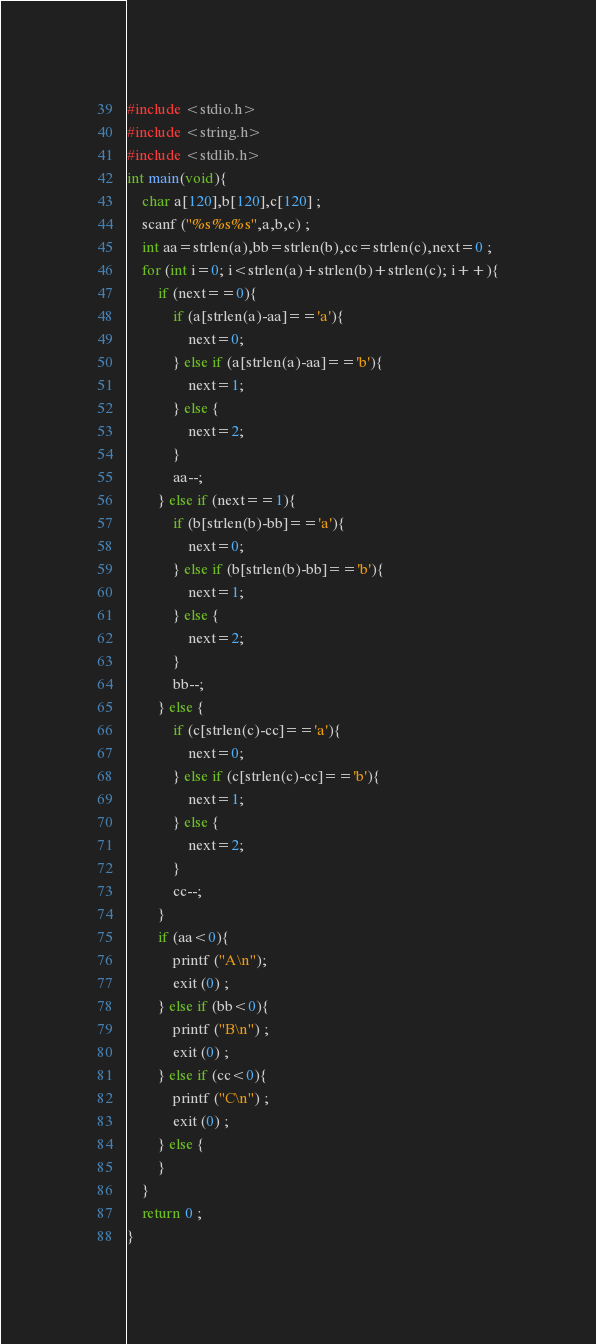<code> <loc_0><loc_0><loc_500><loc_500><_C_>#include <stdio.h>
#include <string.h>
#include <stdlib.h>
int main(void){
    char a[120],b[120],c[120] ;
    scanf ("%s%s%s",a,b,c) ;
    int aa=strlen(a),bb=strlen(b),cc=strlen(c),next=0 ;
    for (int i=0; i<strlen(a)+strlen(b)+strlen(c); i++){
        if (next==0){
            if (a[strlen(a)-aa]=='a'){
                next=0; 
            } else if (a[strlen(a)-aa]=='b'){
                next=1;
            } else {
                next=2;
            }
            aa--;
        } else if (next==1){
            if (b[strlen(b)-bb]=='a'){
                next=0; 
            } else if (b[strlen(b)-bb]=='b'){
                next=1;
            } else {
                next=2;
            }
            bb--;
        } else {
            if (c[strlen(c)-cc]=='a'){
                next=0; 
            } else if (c[strlen(c)-cc]=='b'){
                next=1;
            } else {
                next=2;
            }
            cc--;
        }
        if (aa<0){
            printf ("A\n");
            exit (0) ;
        } else if (bb<0){
            printf ("B\n") ;
            exit (0) ;
        } else if (cc<0){
            printf ("C\n") ;
            exit (0) ;
        } else {
        }
    }
    return 0 ;
}</code> 